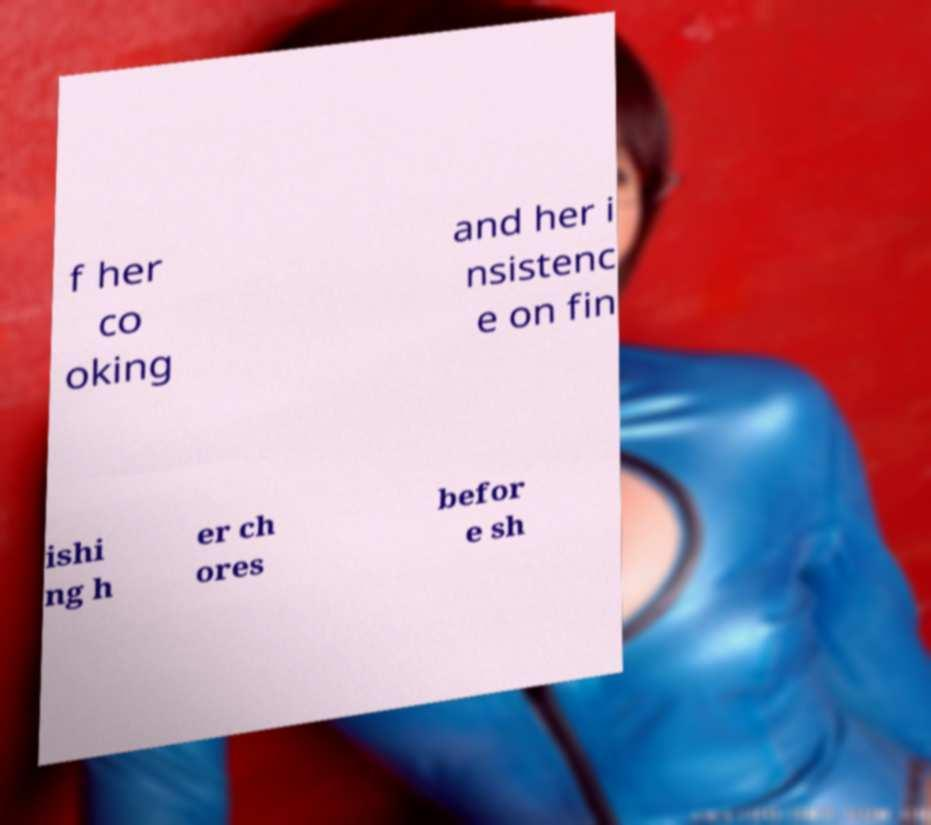Can you accurately transcribe the text from the provided image for me? f her co oking and her i nsistenc e on fin ishi ng h er ch ores befor e sh 